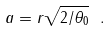Convert formula to latex. <formula><loc_0><loc_0><loc_500><loc_500>a = r \sqrt { 2 / \theta _ { 0 } } \ .</formula> 